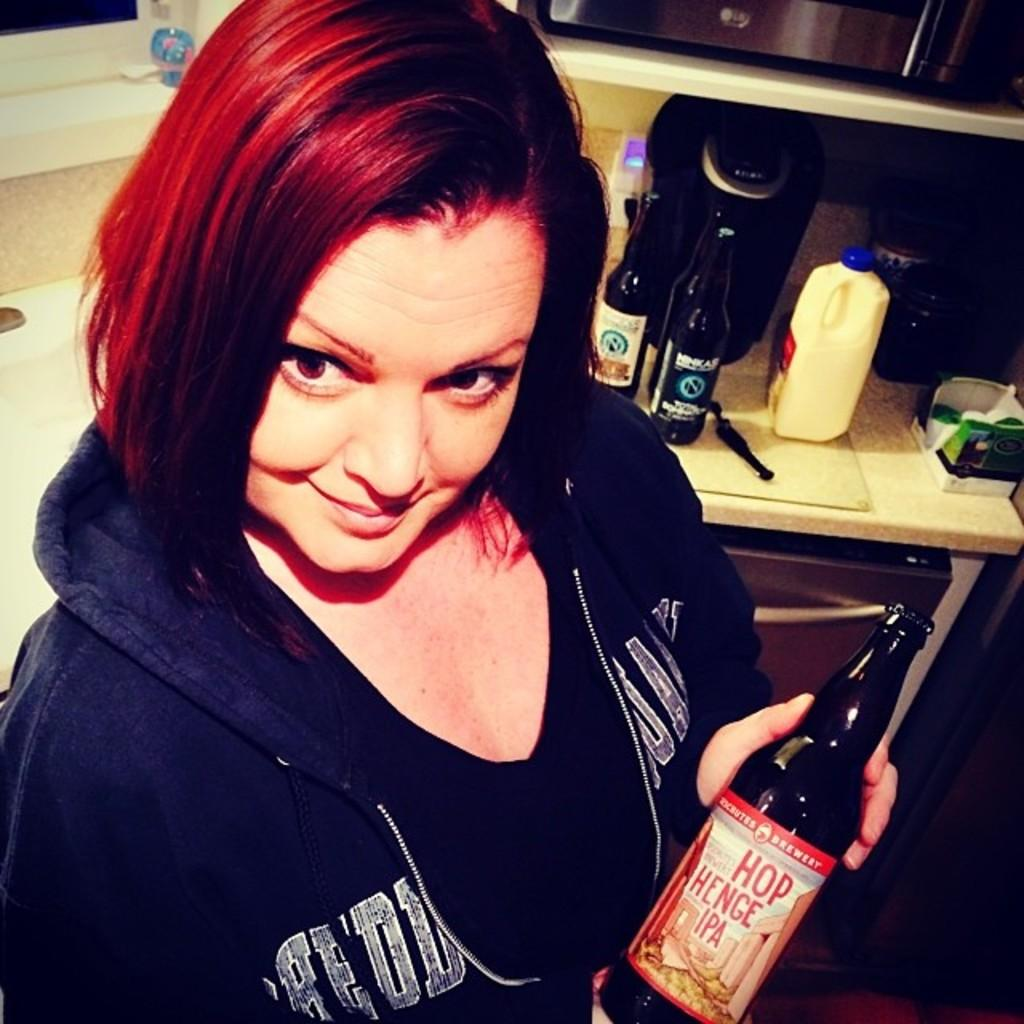Who is present in the image? There is a woman in the image. What is the woman holding in the image? The woman is holding a bottle. What is the woman's facial expression in the image? The woman has a smile on her face. What else can be seen in the background of the image? There are additional bottles visible in the background of the image. What type of operation is being performed on the kettle in the image? There is no kettle present in the image, so no operation can be observed. 